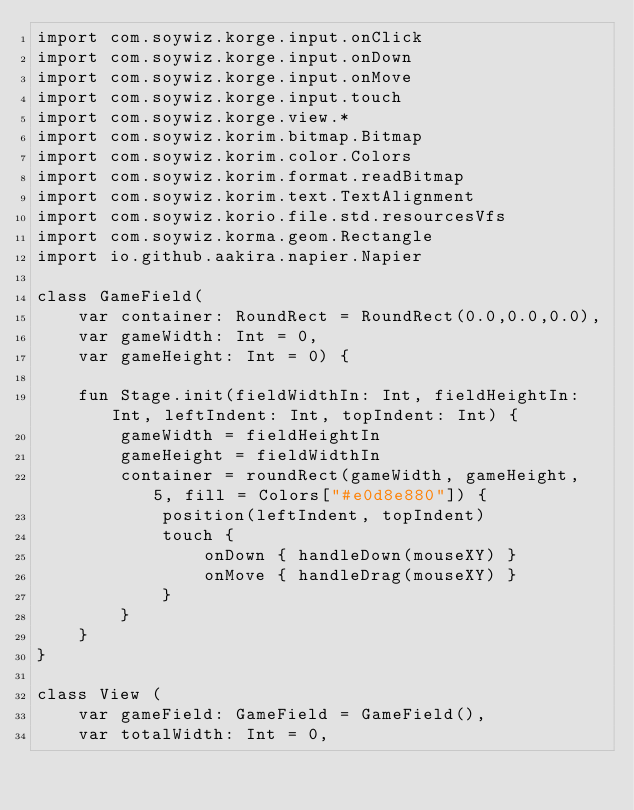<code> <loc_0><loc_0><loc_500><loc_500><_Kotlin_>import com.soywiz.korge.input.onClick
import com.soywiz.korge.input.onDown
import com.soywiz.korge.input.onMove
import com.soywiz.korge.input.touch
import com.soywiz.korge.view.*
import com.soywiz.korim.bitmap.Bitmap
import com.soywiz.korim.color.Colors
import com.soywiz.korim.format.readBitmap
import com.soywiz.korim.text.TextAlignment
import com.soywiz.korio.file.std.resourcesVfs
import com.soywiz.korma.geom.Rectangle
import io.github.aakira.napier.Napier

class GameField(
    var container: RoundRect = RoundRect(0.0,0.0,0.0),
    var gameWidth: Int = 0,
    var gameHeight: Int = 0) {

    fun Stage.init(fieldWidthIn: Int, fieldHeightIn: Int, leftIndent: Int, topIndent: Int) {
        gameWidth = fieldHeightIn
        gameHeight = fieldWidthIn
        container = roundRect(gameWidth, gameHeight, 5, fill = Colors["#e0d8e880"]) {
            position(leftIndent, topIndent)
            touch {
                onDown { handleDown(mouseXY) }
                onMove { handleDrag(mouseXY) }
            }
        }
    }
}

class View (
    var gameField: GameField = GameField(),
    var totalWidth: Int = 0,</code> 